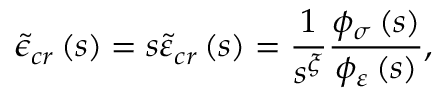Convert formula to latex. <formula><loc_0><loc_0><loc_500><loc_500>\tilde { \epsilon } _ { c r } \left ( s \right ) = s \tilde { \varepsilon } _ { c r } \left ( s \right ) = \frac { 1 } { s ^ { \xi } } \frac { \phi _ { \sigma } \left ( s \right ) } { \phi _ { \varepsilon } \left ( s \right ) } ,</formula> 